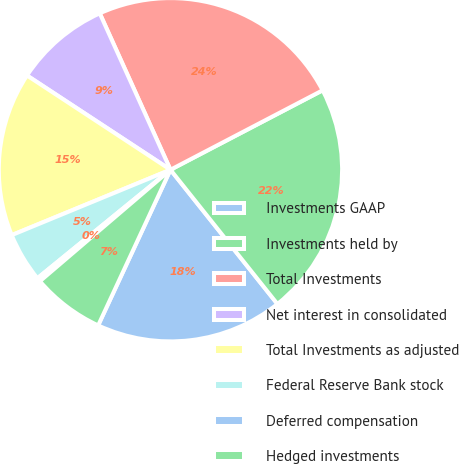<chart> <loc_0><loc_0><loc_500><loc_500><pie_chart><fcel>Investments GAAP<fcel>Investments held by<fcel>Total Investments<fcel>Net interest in consolidated<fcel>Total Investments as adjusted<fcel>Federal Reserve Bank stock<fcel>Deferred compensation<fcel>Hedged investments<nl><fcel>17.63%<fcel>21.95%<fcel>24.1%<fcel>8.99%<fcel>15.47%<fcel>4.67%<fcel>0.36%<fcel>6.83%<nl></chart> 